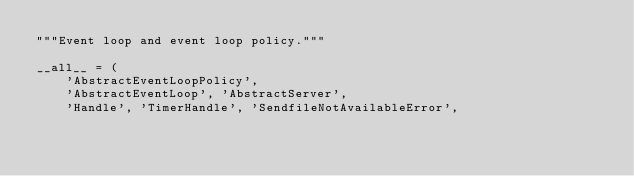<code> <loc_0><loc_0><loc_500><loc_500><_Python_>"""Event loop and event loop policy."""

__all__ = (
    'AbstractEventLoopPolicy',
    'AbstractEventLoop', 'AbstractServer',
    'Handle', 'TimerHandle', 'SendfileNotAvailableError',</code> 